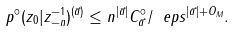<formula> <loc_0><loc_0><loc_500><loc_500>p ^ { \circ } ( z _ { 0 } | z _ { - n } ^ { - 1 } ) ^ { ( \vec { a } ) } \leq n ^ { | \vec { a } | } C ^ { \circ } _ { \vec { a } } / \ e p s ^ { | \vec { a } | + O _ { M } } .</formula> 